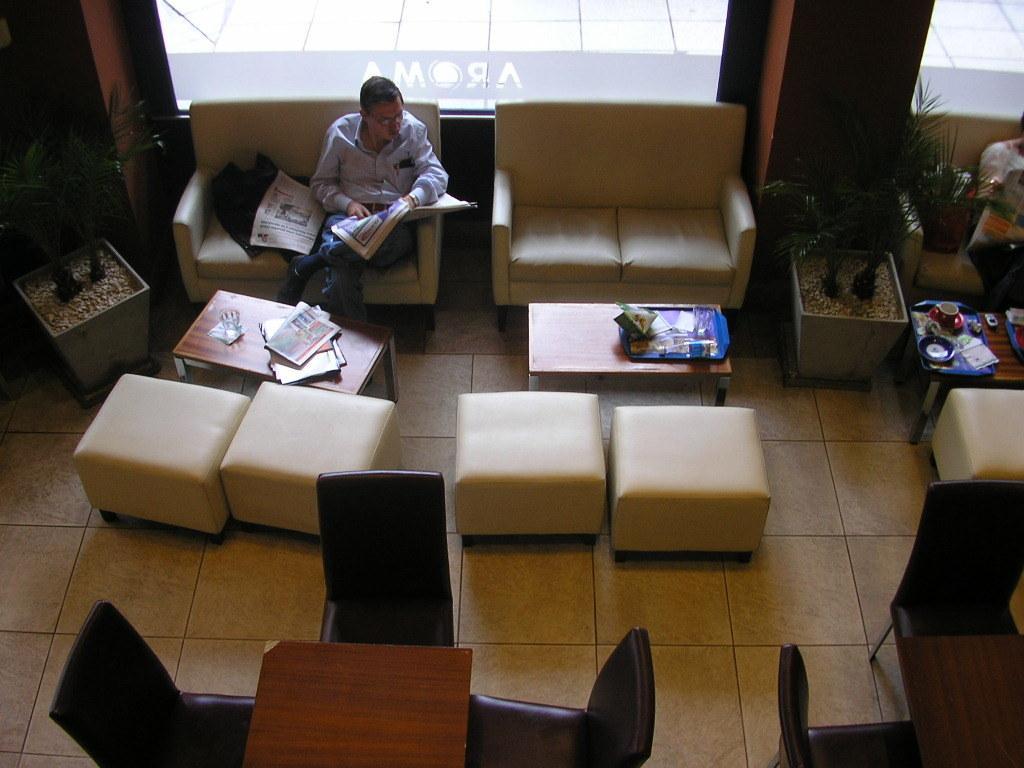In one or two sentences, can you explain what this image depicts? In this picture we can see sofas and chairs and tables. On the table we can see cup and saucer and a plate and also a mobile. This is a floor. This is a houseplant. Here we can see a man sitting on the sofa in front of a table and on the table we can see glass of water and magazines. 